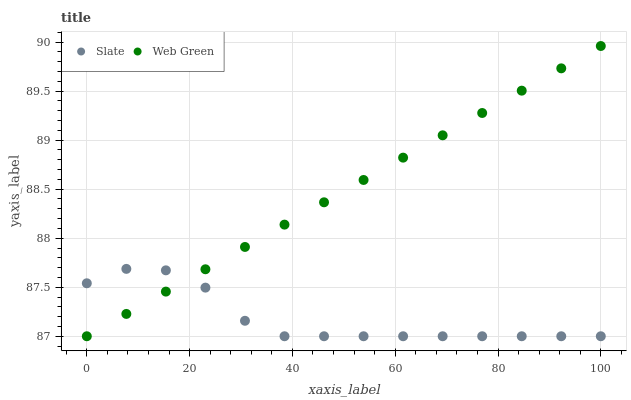Does Slate have the minimum area under the curve?
Answer yes or no. Yes. Does Web Green have the maximum area under the curve?
Answer yes or no. Yes. Does Web Green have the minimum area under the curve?
Answer yes or no. No. Is Web Green the smoothest?
Answer yes or no. Yes. Is Slate the roughest?
Answer yes or no. Yes. Is Web Green the roughest?
Answer yes or no. No. Does Slate have the lowest value?
Answer yes or no. Yes. Does Web Green have the highest value?
Answer yes or no. Yes. Does Slate intersect Web Green?
Answer yes or no. Yes. Is Slate less than Web Green?
Answer yes or no. No. Is Slate greater than Web Green?
Answer yes or no. No. 